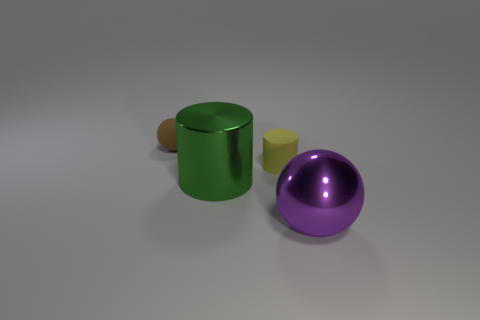Is the big cylinder made of the same material as the ball that is behind the purple shiny ball?
Offer a terse response. No. How many objects are to the left of the tiny rubber cylinder and on the right side of the tiny sphere?
Make the answer very short. 1. What number of other objects are the same material as the tiny cylinder?
Offer a terse response. 1. Is the sphere in front of the tiny ball made of the same material as the small sphere?
Provide a succinct answer. No. What size is the cylinder behind the large metallic object left of the large ball in front of the small yellow matte cylinder?
Your response must be concise. Small. How many other objects are the same color as the large metal cylinder?
Offer a terse response. 0. What shape is the green object that is the same size as the purple metallic sphere?
Your response must be concise. Cylinder. What size is the metal thing that is to the left of the shiny ball?
Give a very brief answer. Large. What material is the sphere right of the big shiny thing behind the shiny thing in front of the shiny cylinder?
Your answer should be very brief. Metal. Is there a metal thing that has the same size as the metal sphere?
Offer a terse response. Yes. 